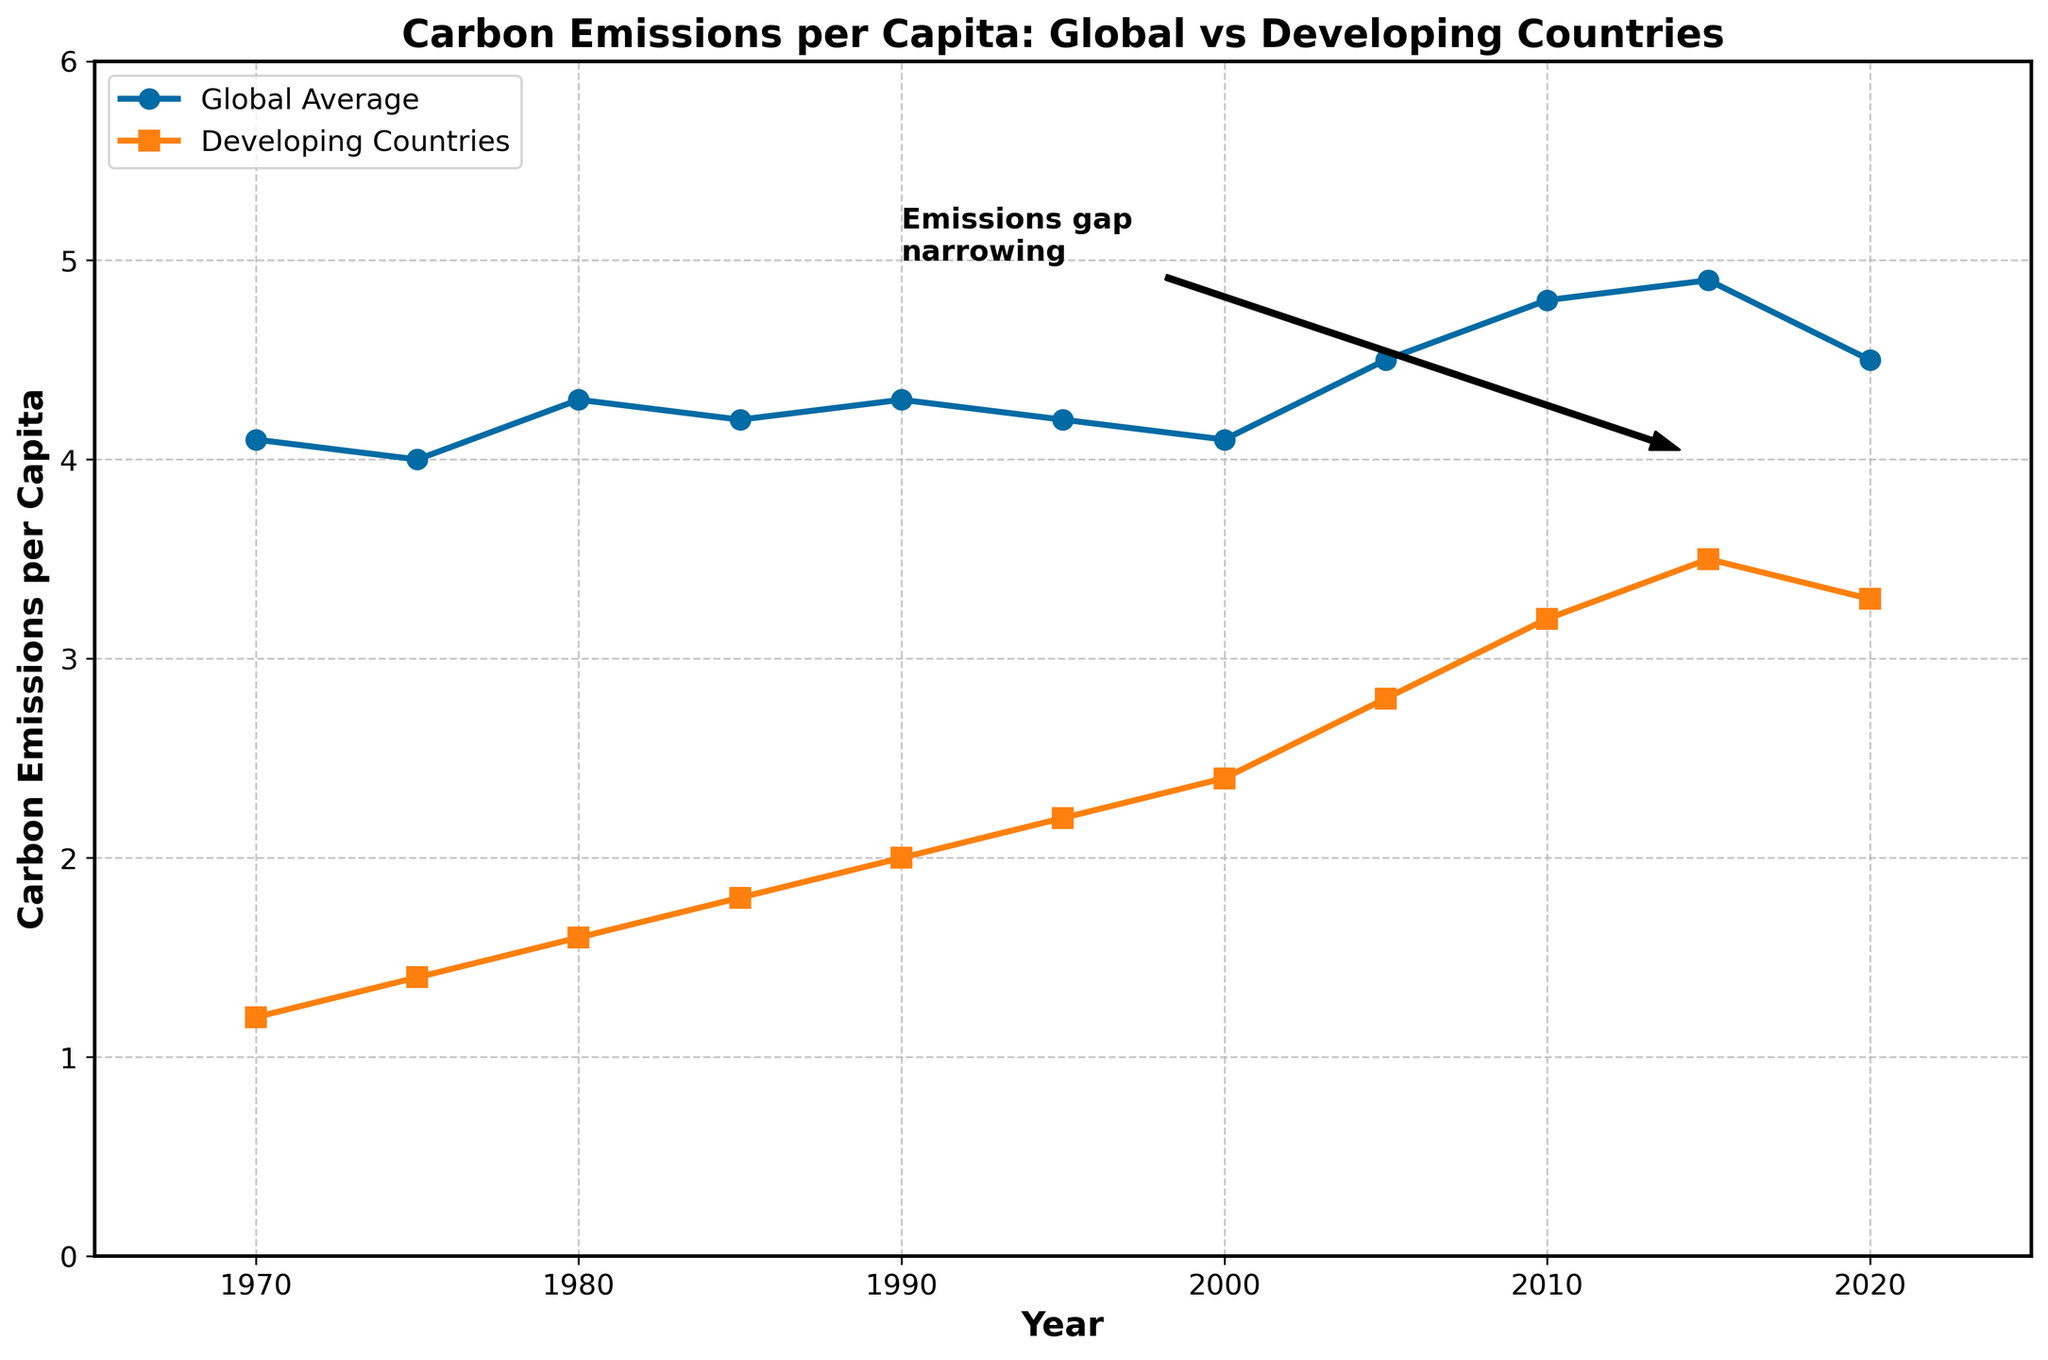What is the difference in carbon emissions per capita between the global average and developing countries in 1970? To find the difference, subtract the value for developing countries (1.2) from the global average (4.1): 4.1 - 1.2 = 2.9
Answer: 2.9 Between which years did developing countries see the largest increase in carbon emissions per capita? By examining the developing countries' data, the largest increase occurred between 2000 and 2005, where the value increased from 2.4 to 2.8. To confirm, compute: 2.8 - 2.4 = 0.4
Answer: 2000 to 2005 How does the carbon emission trend for developing countries compare to the global average from 1970 to 2020? The global average shows minor fluctuations, peaking around 4.9 in 2015 and ending at 4.5 in 2020. In contrast, developing countries' emissions consistently rise over the period from 1.2 in 1970 to 3.5 in 2015 before a slight decrease to 3.3 in 2020
Answer: Developing countries increase steadily, global average fluctuates What is the trend in the gap between the global average and developing countries' carbon emissions per capita from 1970 to 2020? The gap narrows over time, initially 2.9 (in 1970: 4.1 - 1.2) and reducing to 1.2 (in 2020: 4.5 - 3.3). This is indicated visually by the two lines getting closer.
Answer: Gap narrows Which year did the global average emissions per capita peak according to the data? The global average peaks in 2015 with a value of 4.9. This can be identified as the highest point on the global average line.
Answer: 2015 When was the carbon emission per capita for developing countries closest to the corresponding global average? In 2020, the developing countries' value (3.3) is closest to the global average (4.5), making the smallest observed difference.
Answer: 2020 Which year saw the first instance of a visible narrowing in the emissions gap? By examining the plot, a notable narrowing occurs around 2005 when the gap reduces more noticeably compared to previous years.
Answer: 2005 